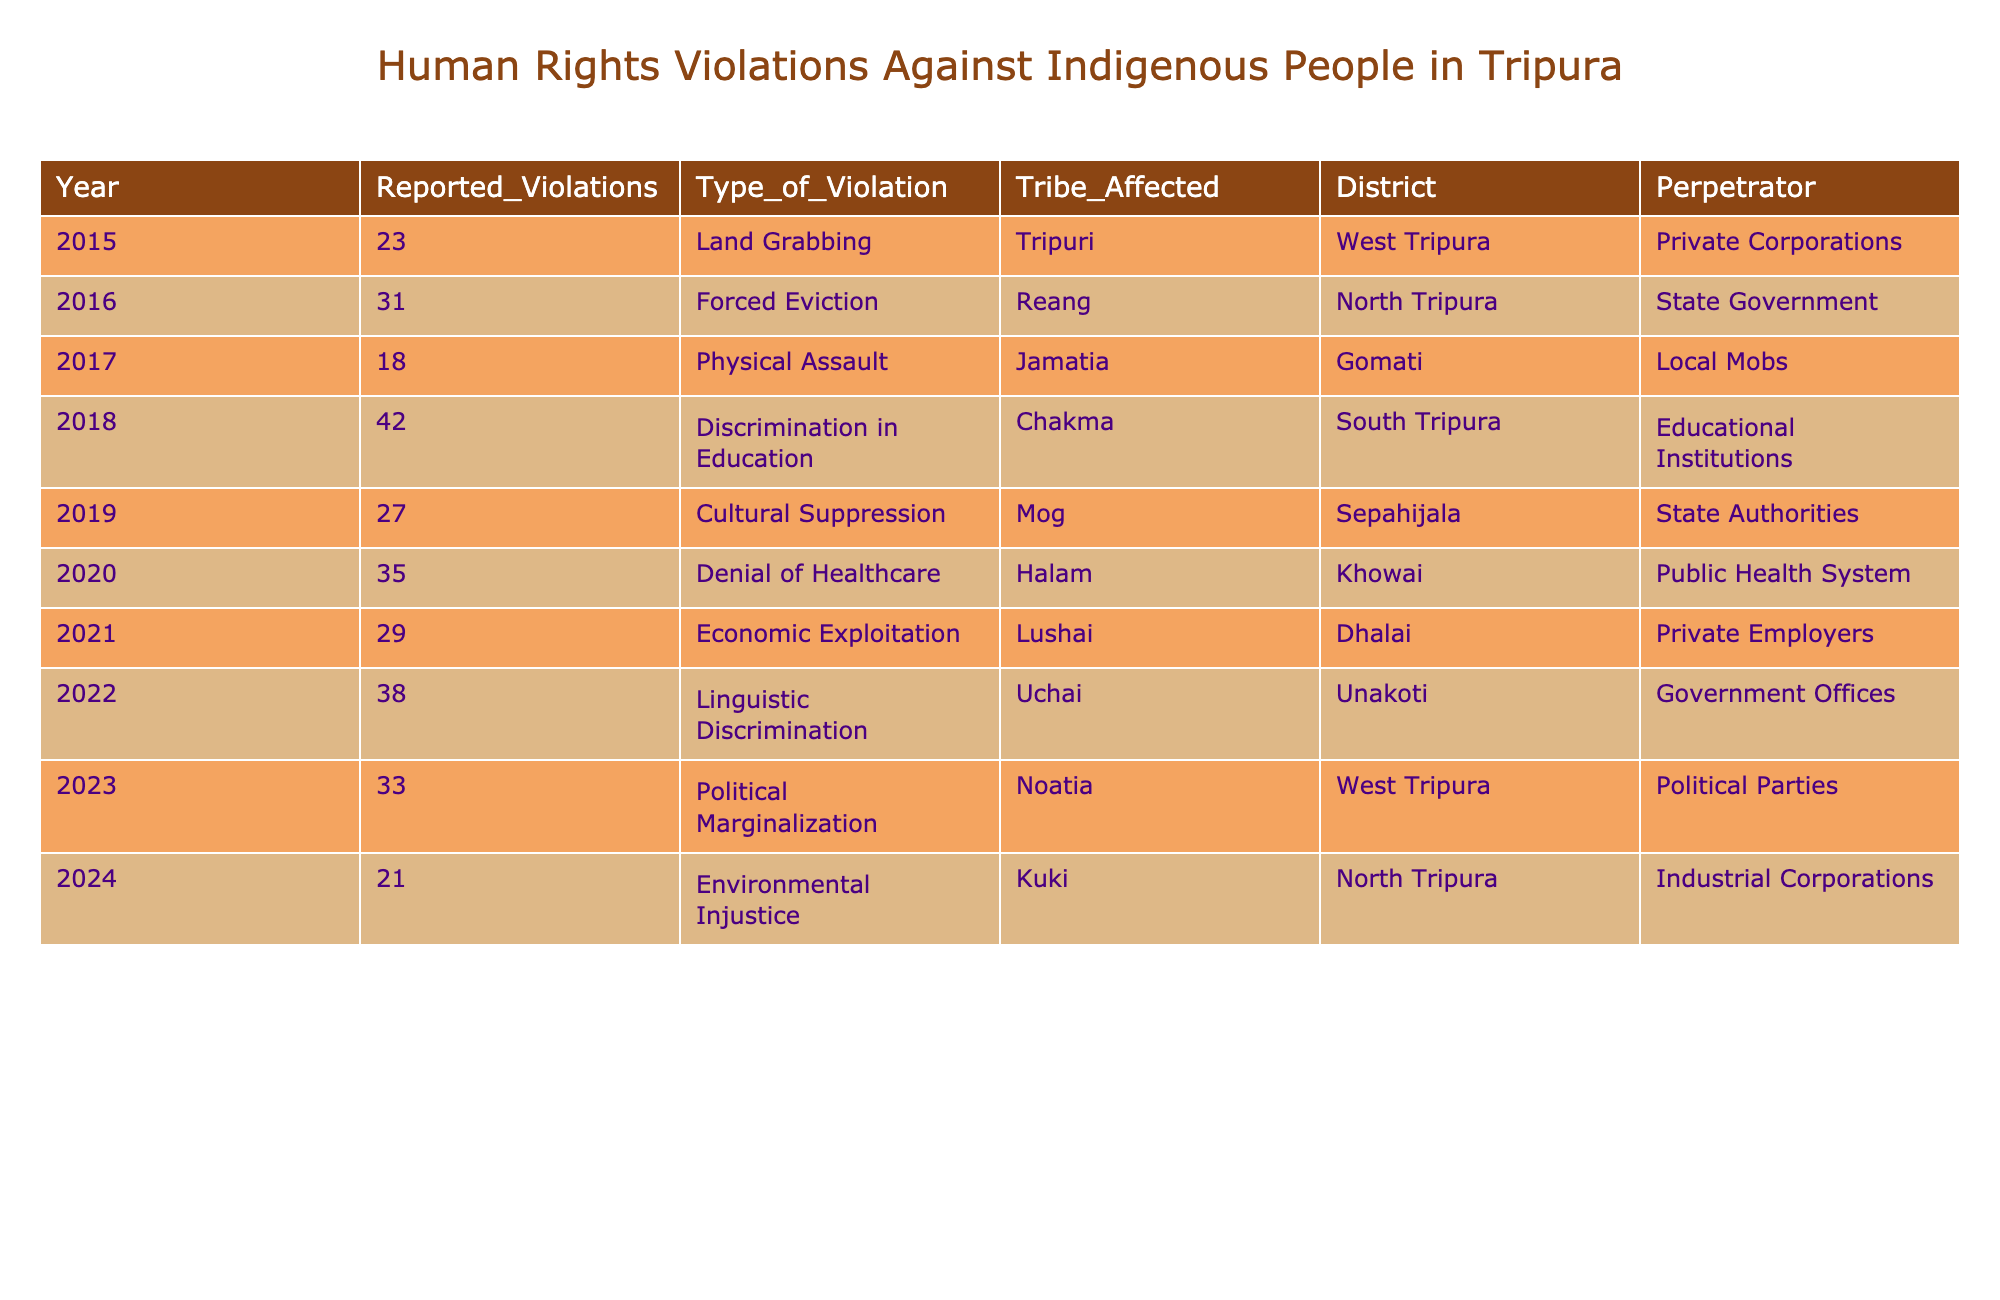What was the highest number of reported human rights violations in a single year? Referring to the table, the highest reported violations occurred in 2018 with 42 violations.
Answer: 42 Which tribe was affected by the most types of violations according to the table? The table shows that the 'Chakma' tribe experienced 'Discrimination in Education' in 2018, listing it as the only unique type specific to them, but they are not the most affected tribe by number.
Answer: Chakma How many reported violations were there in total from 2015 to 2023? Adding the violations year by year: 23 + 31 + 18 + 42 + 27 + 35 + 29 + 38 + 33 =  338 total violations.
Answer: 338 In which year was the most significant violation type "Cultural Suppression" recorded, and how many violations were reported? The table shows that "Cultural Suppression" was recorded in 2019 with a count of 27 violations.
Answer: 2019, 27 Is there evidence of more political marginalization than economic exploitation in Tripura based on this data? Comparing the reported violations, "Political Marginalization" in 2023 recorded 33 violations, whereas "Economic Exploitation" in 2021 recorded 29. Yes, there is more political marginalization.
Answer: Yes What type of violation had the least number of reports according to the table? Upon checking the numbers, "Land Grabbing" in 2015 had the least count with 23 violations.
Answer: Land Grabbing What is the average number of reported violations per year from 2015 to 2024? Summing the reported violations gives 338, then dividing by 9 (the years) gives 338/9 ≈ 37.56, which rounds to approximately 38 reported violations per year.
Answer: Approximately 38 In which district did the highest reported violation occur, and what was the type of violation? The highest violation count of 42 in 2018 occurred in South Tripura for "Discrimination in Education."
Answer: South Tripura, Discrimination in Education What is the total number of reported violations specifically under the category of "Denial of Healthcare"? The table indicates that there were 35 violations under "Denial of Healthcare" in 2020.
Answer: 35 Was the perpetrator mostly state authorities or private corporations in the reported violations? The table includes state authorities in 2019 and 2023, and private corporations in 2015 and 2024. However, private corporations appear twice, suggesting they are slightly more frequent as perpetrators.
Answer: Private Corporations 